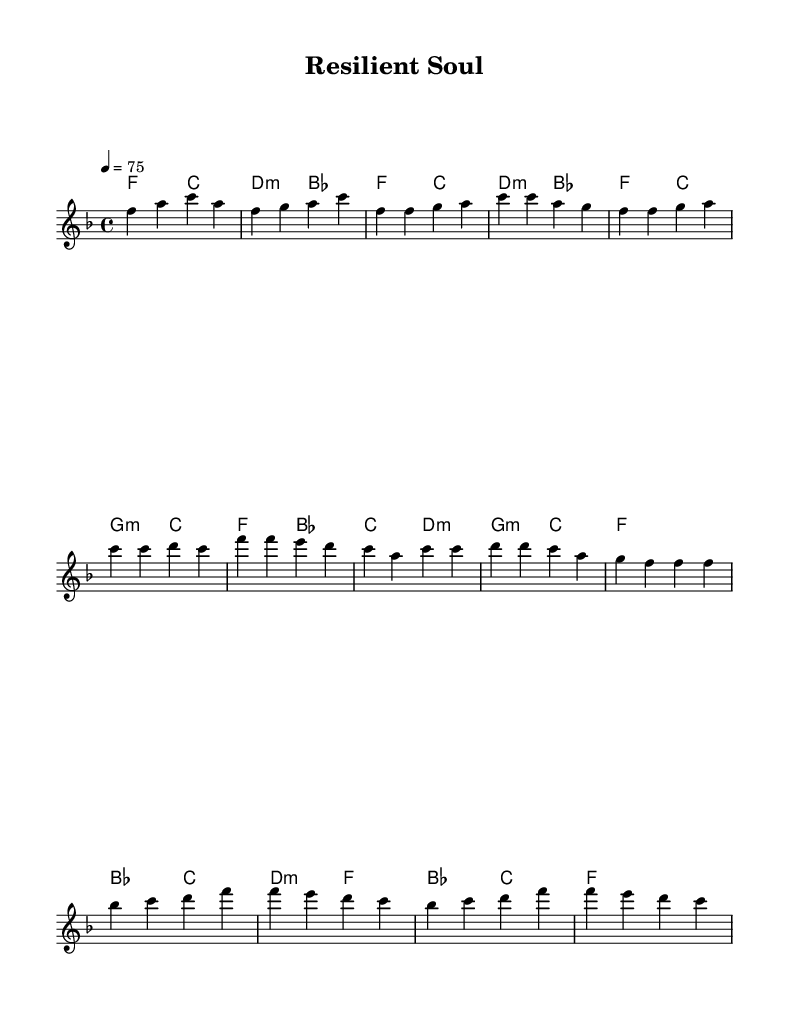What is the key signature of this music? The key signature indicates the presence of one flat, which represents F major. This is identifiable in the first measure where the key is stated.
Answer: F major What is the time signature of this music? The time signature shown at the beginning of the score is 4/4, which is typically displayed as a fraction indicating that there are four beats in each measure.
Answer: 4/4 What is the tempo marking for this piece? The tempo of the piece is indicated as "4 = 75," meaning the quarter note should be played at a speed of 75 beats per minute. This can be identified in the tempo section of the score.
Answer: 75 How many measures are in the chorus section? By counting the measures specifically represented in the chorus section, we observe that it consists of four measures, which can be directly seen from the score structure.
Answer: 4 What is the first chord of the bridge? The first chord in the bridge is shown as B flat major, which is identified in the chord notation aligned with the melody in the bridge section of the score.
Answer: B flat What is the overall theme reflected in the song? The song reflects themes of resilience and personal growth, as indicated by its title "Resilient Soul," suggesting emotional and personal strength within its structure and melody.
Answer: Resilience What types of chords are predominantly used in the harmonies? The harmonies predominantly feature major and minor chords, which are noted in the chord progression throughout the score indicated by symbols such as "f," "c," and "g:m."
Answer: Major and minor 